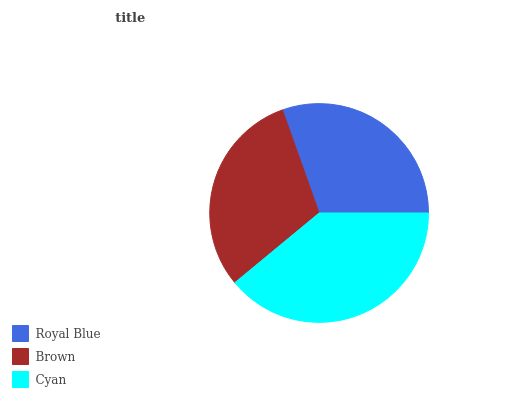Is Royal Blue the minimum?
Answer yes or no. Yes. Is Cyan the maximum?
Answer yes or no. Yes. Is Brown the minimum?
Answer yes or no. No. Is Brown the maximum?
Answer yes or no. No. Is Brown greater than Royal Blue?
Answer yes or no. Yes. Is Royal Blue less than Brown?
Answer yes or no. Yes. Is Royal Blue greater than Brown?
Answer yes or no. No. Is Brown less than Royal Blue?
Answer yes or no. No. Is Brown the high median?
Answer yes or no. Yes. Is Brown the low median?
Answer yes or no. Yes. Is Cyan the high median?
Answer yes or no. No. Is Cyan the low median?
Answer yes or no. No. 